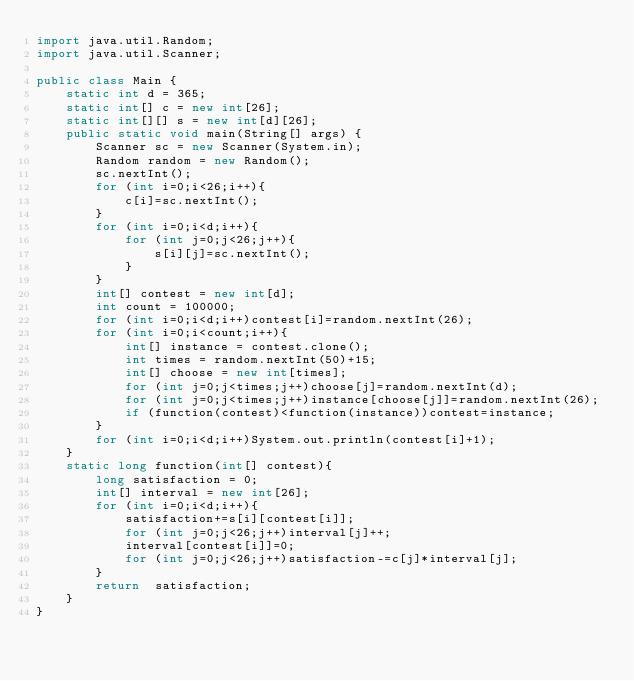<code> <loc_0><loc_0><loc_500><loc_500><_Java_>import java.util.Random;
import java.util.Scanner;

public class Main {
    static int d = 365;
    static int[] c = new int[26];
    static int[][] s = new int[d][26];
    public static void main(String[] args) {
        Scanner sc = new Scanner(System.in);
        Random random = new Random();
        sc.nextInt();
        for (int i=0;i<26;i++){
            c[i]=sc.nextInt();
        }
        for (int i=0;i<d;i++){
            for (int j=0;j<26;j++){
                s[i][j]=sc.nextInt();
            }
        }
        int[] contest = new int[d];
        int count = 100000;
        for (int i=0;i<d;i++)contest[i]=random.nextInt(26);
        for (int i=0;i<count;i++){
            int[] instance = contest.clone();
            int times = random.nextInt(50)+15;
            int[] choose = new int[times];
            for (int j=0;j<times;j++)choose[j]=random.nextInt(d);
            for (int j=0;j<times;j++)instance[choose[j]]=random.nextInt(26);
            if (function(contest)<function(instance))contest=instance;
        }
        for (int i=0;i<d;i++)System.out.println(contest[i]+1);
    }
    static long function(int[] contest){
        long satisfaction = 0;
        int[] interval = new int[26];
        for (int i=0;i<d;i++){
            satisfaction+=s[i][contest[i]];
            for (int j=0;j<26;j++)interval[j]++;
            interval[contest[i]]=0;
            for (int j=0;j<26;j++)satisfaction-=c[j]*interval[j];
        }
        return  satisfaction;
    }
}
</code> 